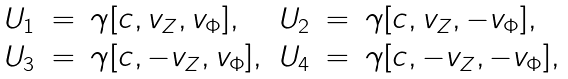<formula> <loc_0><loc_0><loc_500><loc_500>\begin{array} { r c l r c l } U _ { 1 } & = & \gamma [ c , v _ { Z } , v _ { \Phi } ] , & U _ { 2 } & = & \gamma [ c , v _ { Z } , - v _ { \Phi } ] , \\ U _ { 3 } & = & \gamma [ c , - v _ { Z } , v _ { \Phi } ] , & U _ { 4 } & = & \gamma [ c , - v _ { Z } , - v _ { \Phi } ] , \end{array}</formula> 